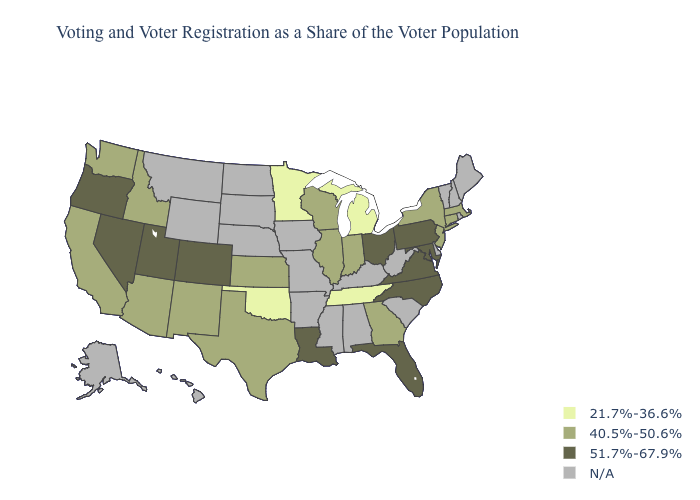What is the lowest value in states that border Virginia?
Write a very short answer. 21.7%-36.6%. Among the states that border Nebraska , which have the highest value?
Quick response, please. Colorado. Name the states that have a value in the range 51.7%-67.9%?
Keep it brief. Colorado, Florida, Louisiana, Maryland, Nevada, North Carolina, Ohio, Oregon, Pennsylvania, Utah, Virginia. What is the value of Texas?
Short answer required. 40.5%-50.6%. What is the highest value in states that border Delaware?
Give a very brief answer. 51.7%-67.9%. Name the states that have a value in the range N/A?
Short answer required. Alabama, Alaska, Arkansas, Delaware, Hawaii, Iowa, Kentucky, Maine, Mississippi, Missouri, Montana, Nebraska, New Hampshire, North Dakota, Rhode Island, South Carolina, South Dakota, Vermont, West Virginia, Wyoming. Among the states that border North Dakota , which have the lowest value?
Quick response, please. Minnesota. Name the states that have a value in the range 21.7%-36.6%?
Quick response, please. Michigan, Minnesota, Oklahoma, Tennessee. What is the lowest value in the Northeast?
Be succinct. 40.5%-50.6%. What is the lowest value in the West?
Write a very short answer. 40.5%-50.6%. What is the value of Hawaii?
Short answer required. N/A. 